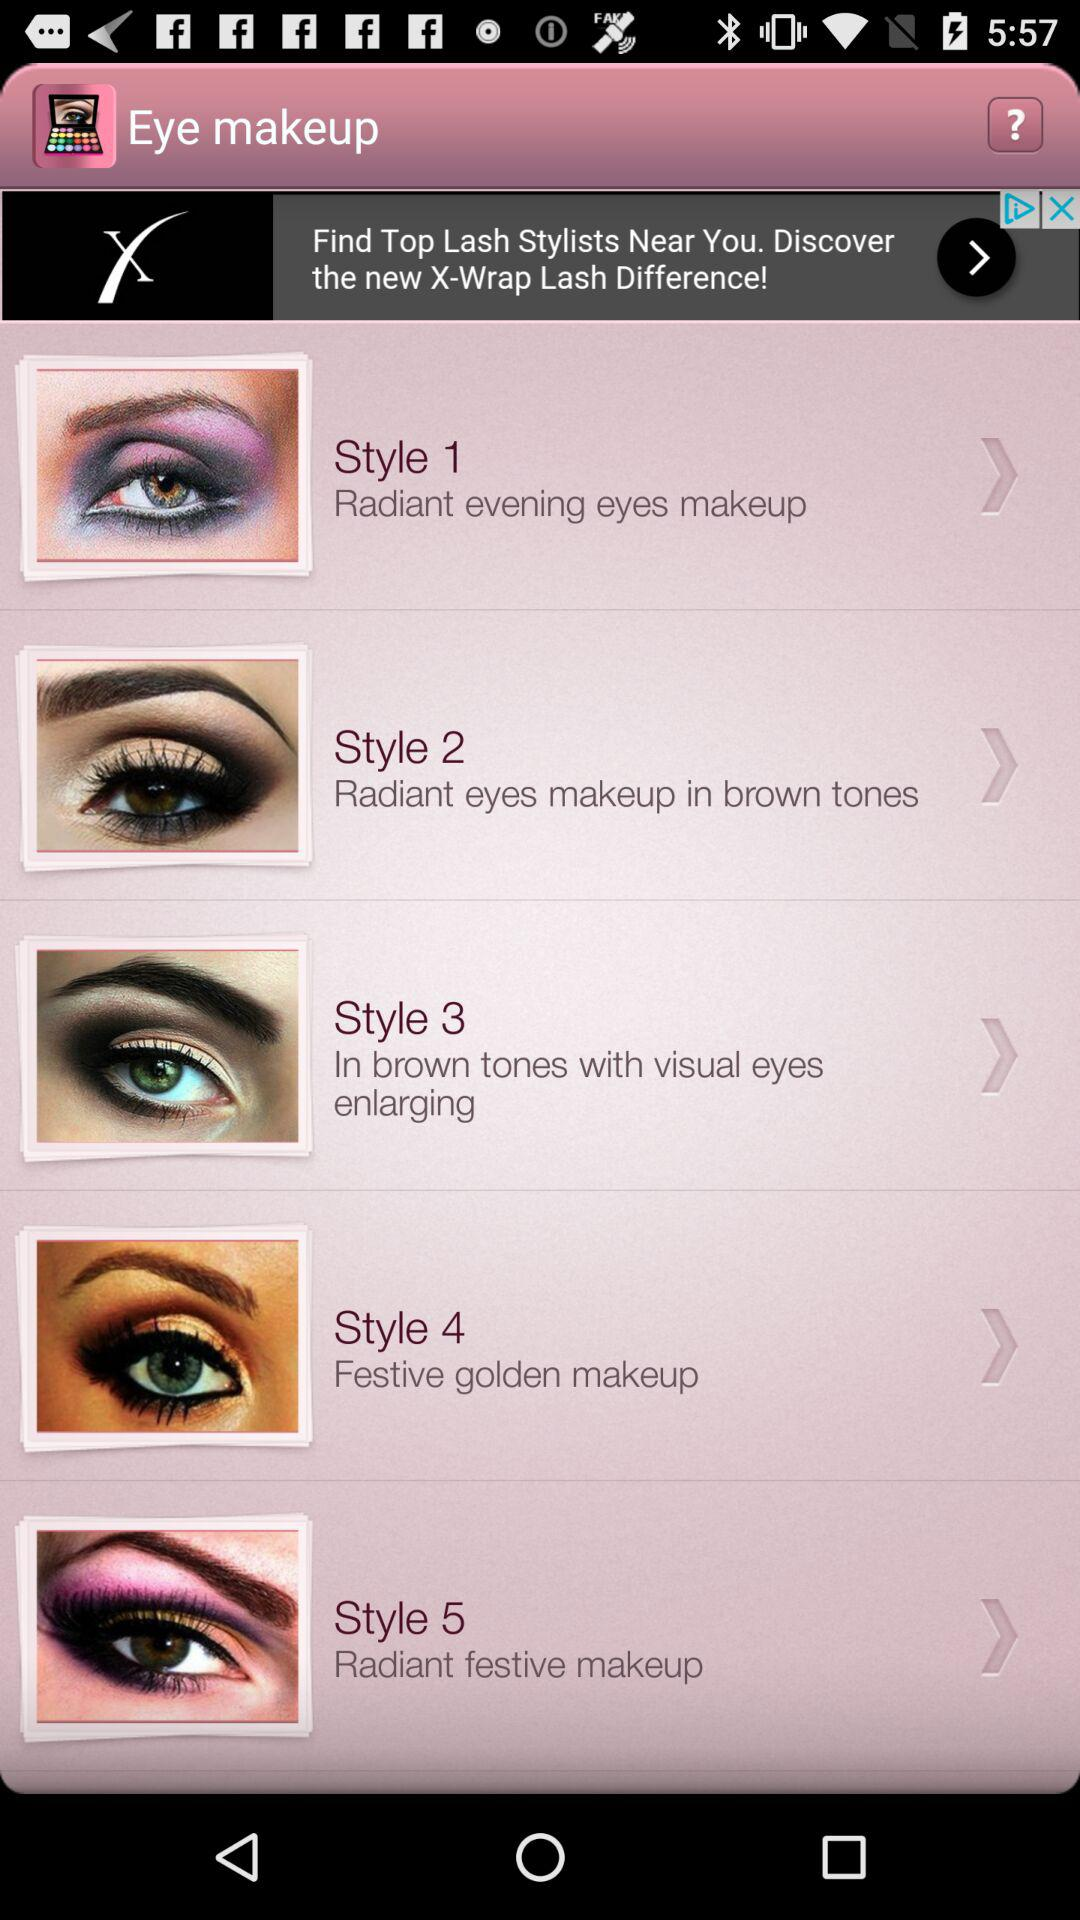What is the name of the application? The name of the application is "Eye makeup". 